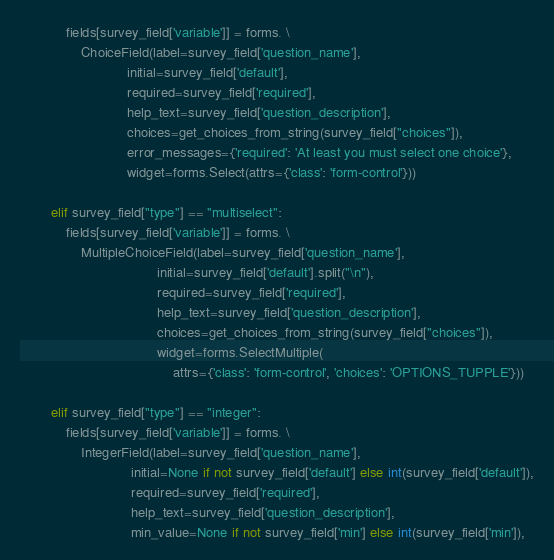<code> <loc_0><loc_0><loc_500><loc_500><_Python_>            fields[survey_field['variable']] = forms. \
                ChoiceField(label=survey_field['question_name'],
                            initial=survey_field['default'],
                            required=survey_field['required'],
                            help_text=survey_field['question_description'],
                            choices=get_choices_from_string(survey_field["choices"]),
                            error_messages={'required': 'At least you must select one choice'},
                            widget=forms.Select(attrs={'class': 'form-control'}))

        elif survey_field["type"] == "multiselect":
            fields[survey_field['variable']] = forms. \
                MultipleChoiceField(label=survey_field['question_name'],
                                    initial=survey_field['default'].split("\n"),
                                    required=survey_field['required'],
                                    help_text=survey_field['question_description'],
                                    choices=get_choices_from_string(survey_field["choices"]),
                                    widget=forms.SelectMultiple(
                                        attrs={'class': 'form-control', 'choices': 'OPTIONS_TUPPLE'}))

        elif survey_field["type"] == "integer":
            fields[survey_field['variable']] = forms. \
                IntegerField(label=survey_field['question_name'],
                             initial=None if not survey_field['default'] else int(survey_field['default']),
                             required=survey_field['required'],
                             help_text=survey_field['question_description'],
                             min_value=None if not survey_field['min'] else int(survey_field['min']),</code> 